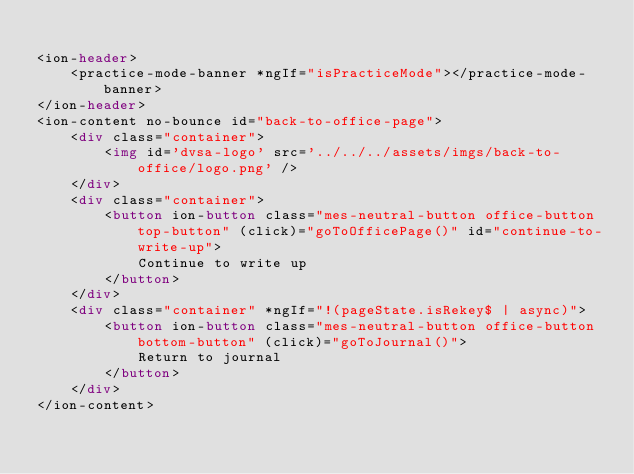Convert code to text. <code><loc_0><loc_0><loc_500><loc_500><_HTML_>
<ion-header>
    <practice-mode-banner *ngIf="isPracticeMode"></practice-mode-banner>
</ion-header>
<ion-content no-bounce id="back-to-office-page">
    <div class="container">
        <img id='dvsa-logo' src='../../../assets/imgs/back-to-office/logo.png' />
    </div>
    <div class="container">
        <button ion-button class="mes-neutral-button office-button top-button" (click)="goToOfficePage()" id="continue-to-write-up">
            Continue to write up
        </button>
    </div>
    <div class="container" *ngIf="!(pageState.isRekey$ | async)">
        <button ion-button class="mes-neutral-button office-button bottom-button" (click)="goToJournal()">
            Return to journal
        </button>
    </div>
</ion-content>
</code> 